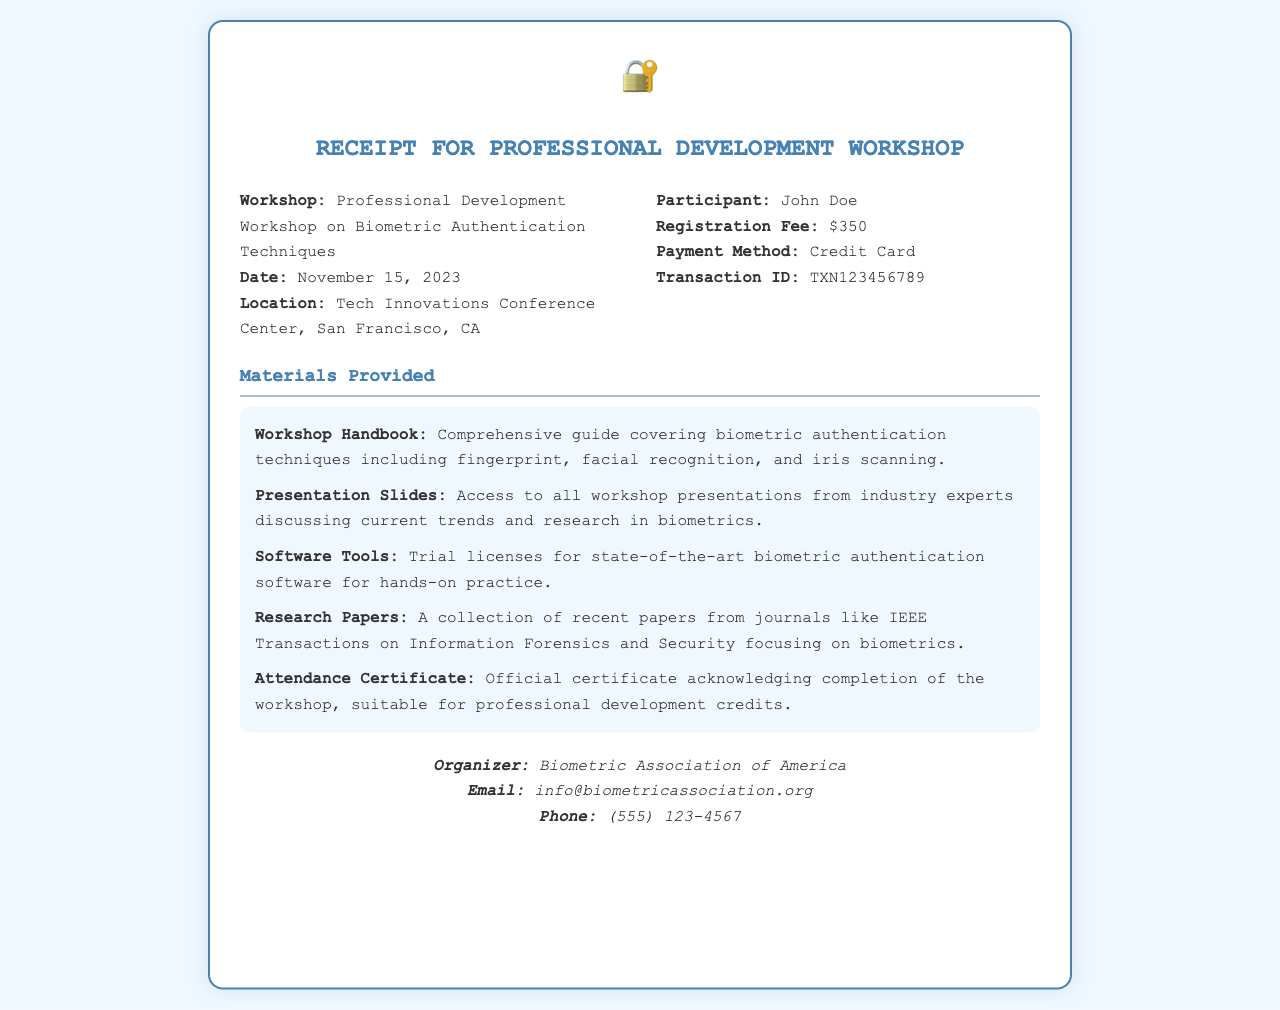What is the name of the workshop? The name of the workshop is clearly stated in the document as "Professional Development Workshop on Biometric Authentication Techniques."
Answer: Professional Development Workshop on Biometric Authentication Techniques What is the date of the workshop? The date of the workshop is specified in the document, making it easy to retrieve.
Answer: November 15, 2023 What was the registration fee? The registration fee is listed overtly in the information section of the document.
Answer: $350 Who is the participant? The name of the participant is provided in the receipt, making it straightforward to find.
Answer: John Doe What materials are provided? Materials provided are highlighted in the document; each item lists specific resources related to the workshop.
Answer: Workshop Handbook, Presentation Slides, Software Tools, Research Papers, Attendance Certificate What is the payment method? The payment method is documented in the participant's information section within the receipt.
Answer: Credit Card What organization organized the workshop? The organizer is mentioned prominently in the contact section of the document.
Answer: Biometric Association of America What type of certificate is provided? The type of certificate provided is specified in the materials section, which details the benefits of the certificate.
Answer: Attendance Certificate What is the contact email for the organizer? The contact email is included at the bottom of the receipt, easily accessible for inquiries.
Answer: info@biometricassociation.org 